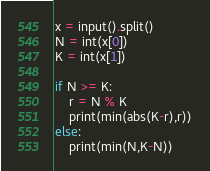<code> <loc_0><loc_0><loc_500><loc_500><_Python_>x = input().split()
N = int(x[0])
K = int(x[1])

if N >= K:
    r = N % K 
    print(min(abs(K-r),r))
else:
    print(min(N,K-N))</code> 